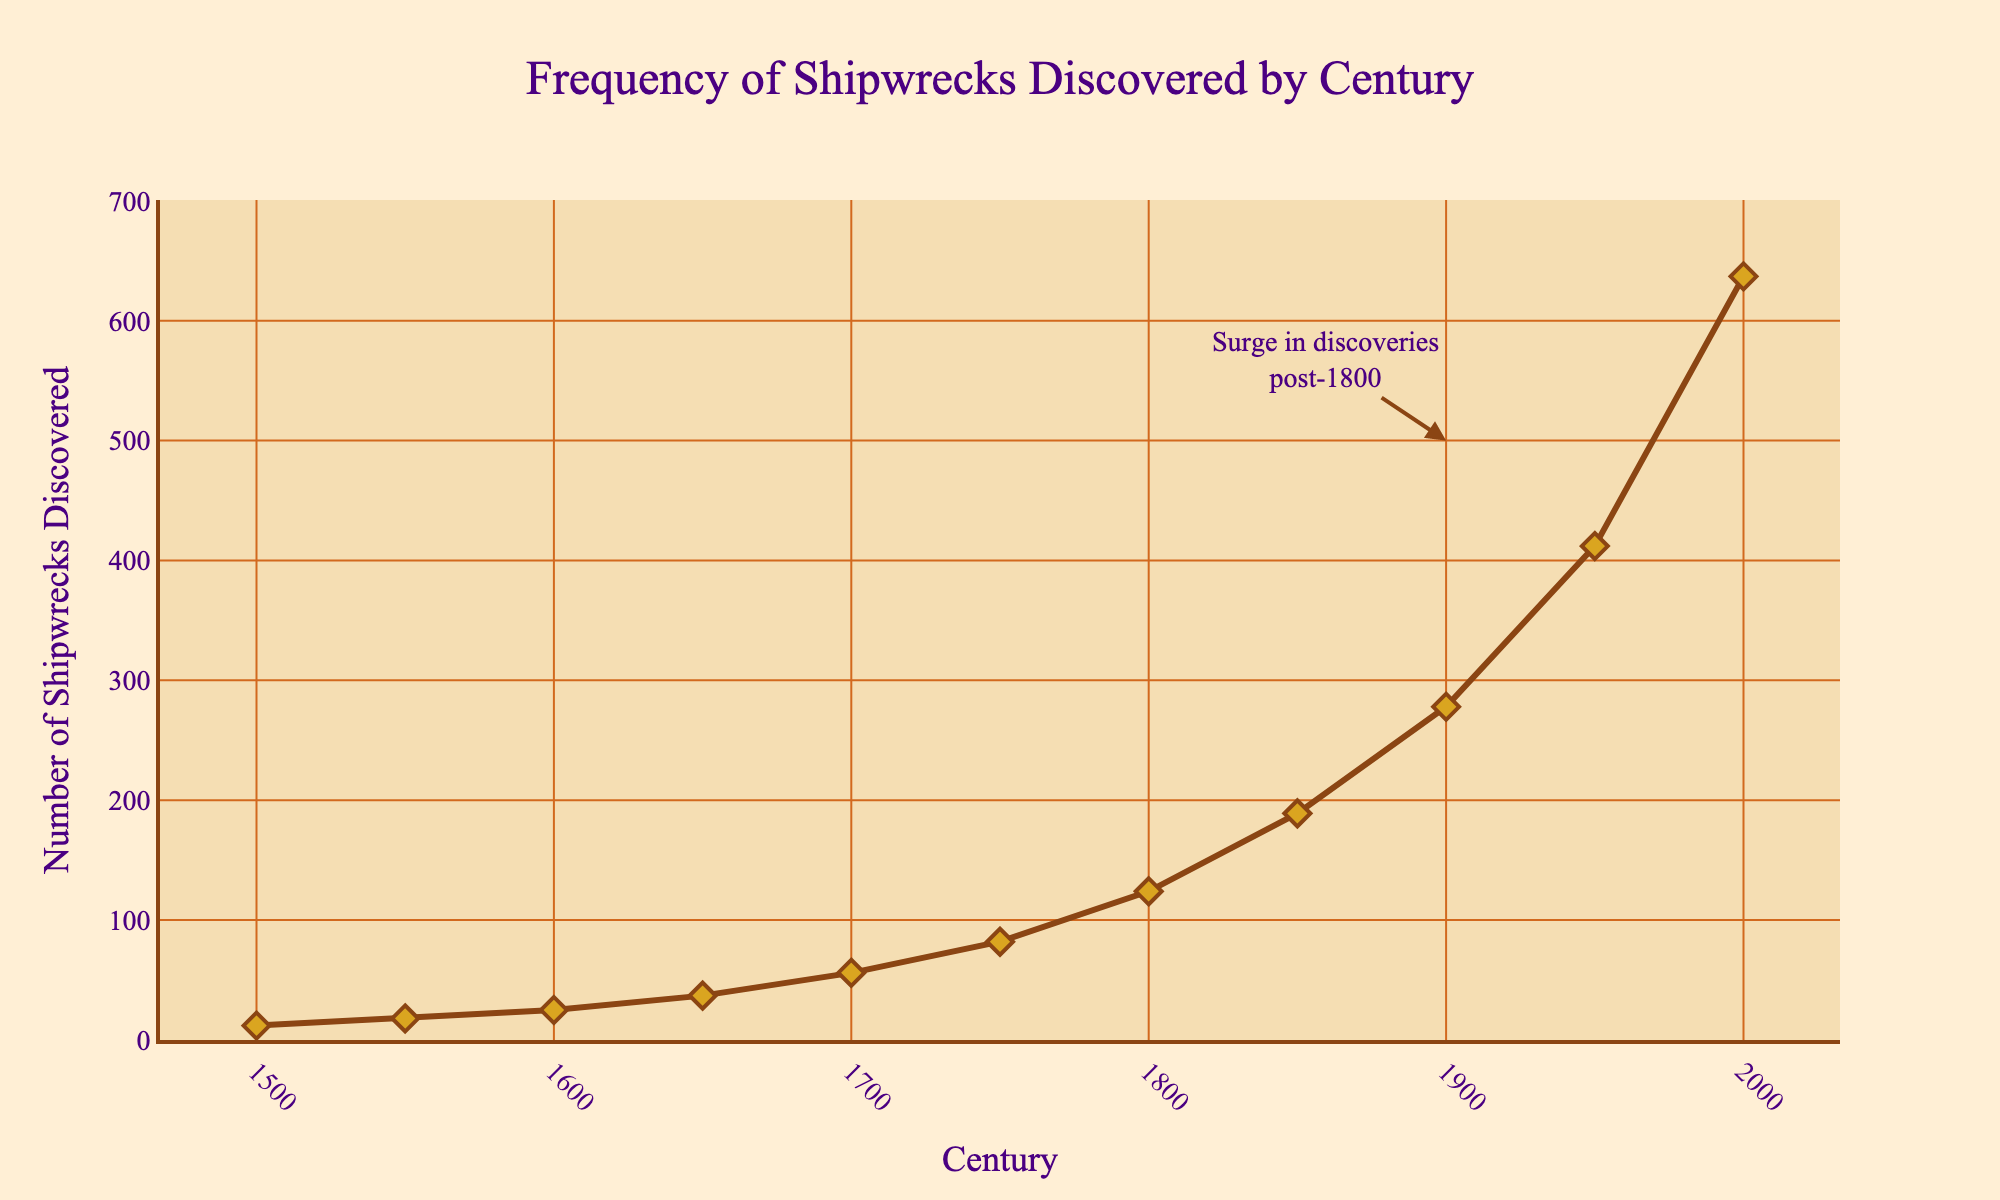how many more shipwrecks were discovered in the 2000s compared to the 1800s? In the 2000s, there were 637 shipwrecks discovered, and in the 1800s, there were 124 shipwrecks discovered. The difference is 637 - 124.
Answer: 513 during which century did the number of shipwreck discoveries first exceed 100? The number of shipwreck discoveries first exceeded 100 in the 1800s, when the number reached 124.
Answer: 1800s What is the average number of shipwrecks discovered per century from 1500 to 2000? Sum the number of shipwrecks discovered from 1500 to 2000 which is 12 + 18 + 25 + 37 + 56 + 82 + 124 + 189 + 278 + 412 + 637. There are 11 centuries in this range, so divide the sum by 11.
Answer: 169 How did the number of shipwreck discoveries change between 1950 and 2000? In 1950, the number of shipwrecks discovered was 412, and in 2000, it was 637. The increase is 637 - 412.
Answer: Increase by 225 Between which two consecutive centuries did the largest increase in discoveries occur? By examining the increases between each consecutive century, the largest increase is between 1900 (278) and 1950 (412), with an increase of 412 - 278.
Answer: Between 1900 and 1950 is the increase in shipwreck discoveries from 1550 to 1650 smaller or greater than the increase from 1650 to 1750? The increase from 1550 (18) to 1650 (37) is 37 - 18 = 19. The increase from 1650 (37) to 1750 (82) is 82 - 37 = 45. Therefore, the increase from 1550 to 1650 is smaller.
Answer: Smaller What visual sign indicates a significant increase in shipwreck discoveries post-1800? There is an annotation near the data points on the plot, around the 1900s, mentioning "Surge in discoveries post-1800." This visual cue indicates a significant increase.
Answer: Annotation What is depicted with diamond markers on the line plot? Each data point representing the number of shipwrecks discovered in a particular century is marked with a diamond symbol on the line plot.
Answer: Shipwrecks 